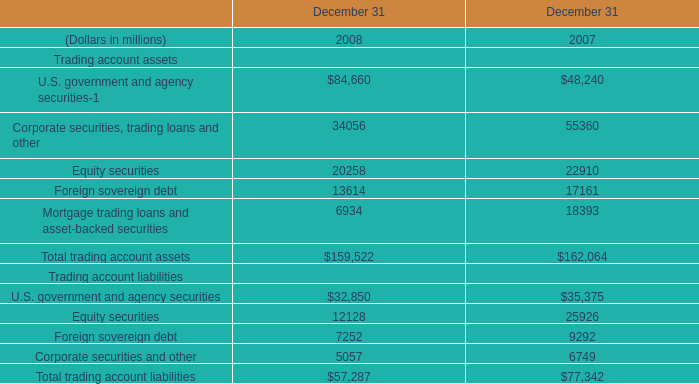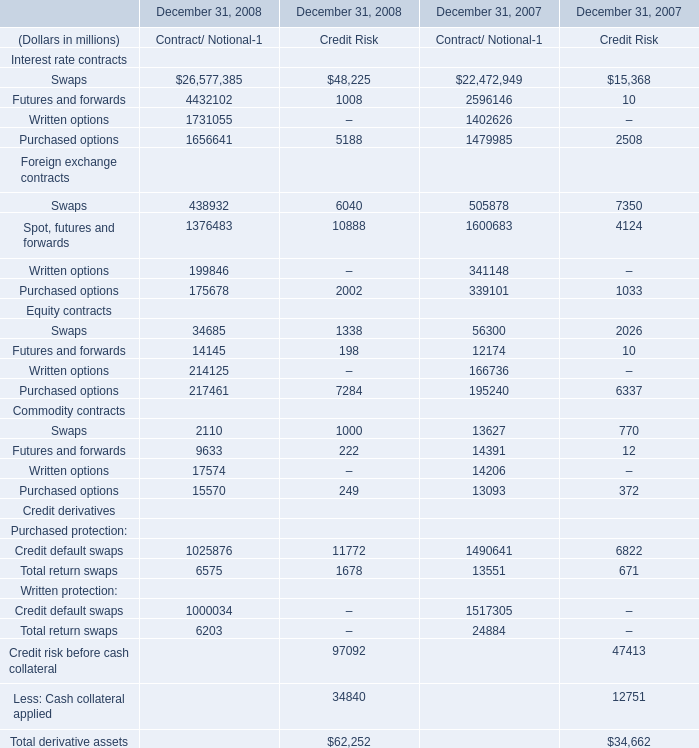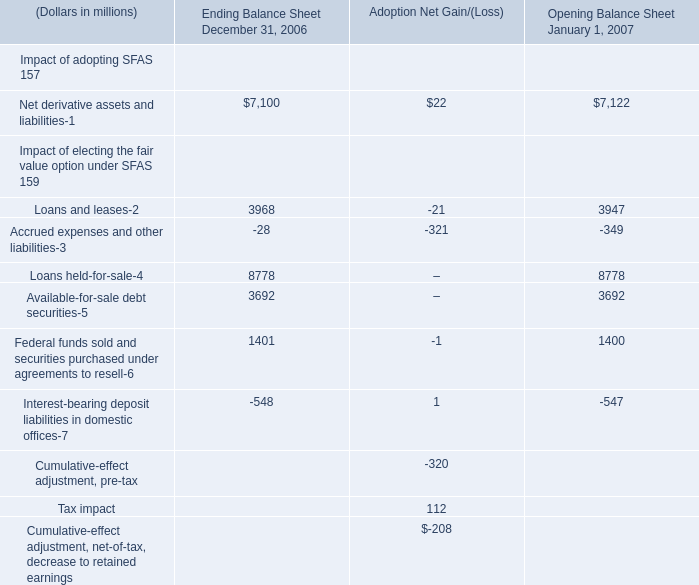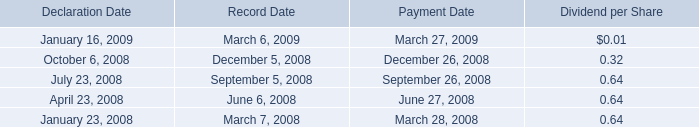If total trading account liabilities develops with the same growth rate in 2008, what will it reach in 2009? (in million) 
Computations: ((((57287 - 77342) / 77342) + 1) * 57287)
Answer: 42432.31839. 